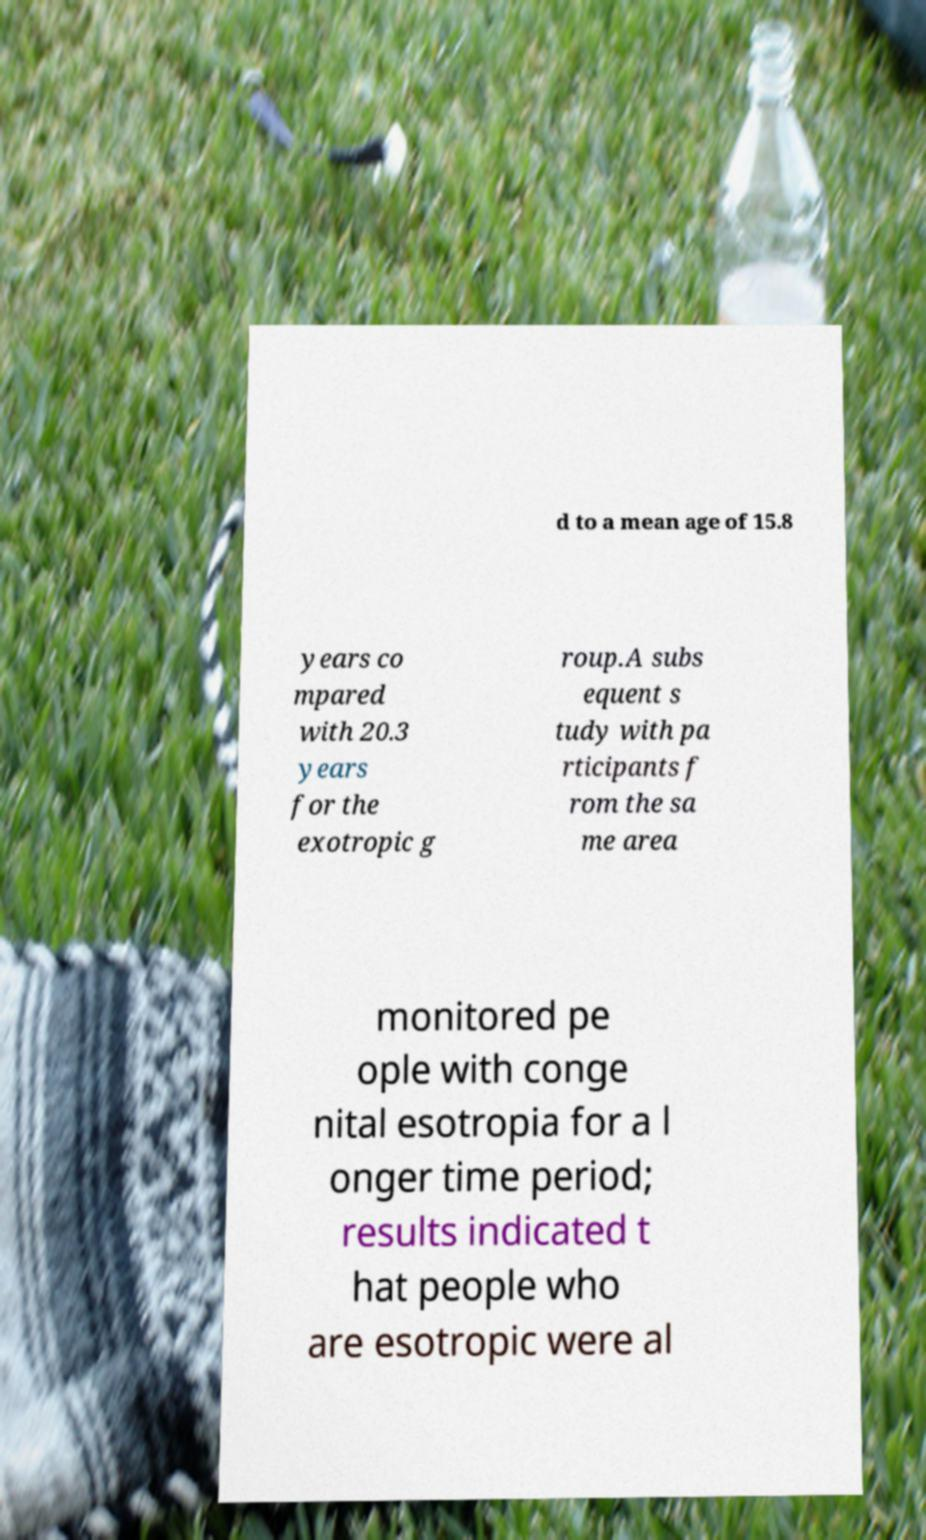Please identify and transcribe the text found in this image. d to a mean age of 15.8 years co mpared with 20.3 years for the exotropic g roup.A subs equent s tudy with pa rticipants f rom the sa me area monitored pe ople with conge nital esotropia for a l onger time period; results indicated t hat people who are esotropic were al 